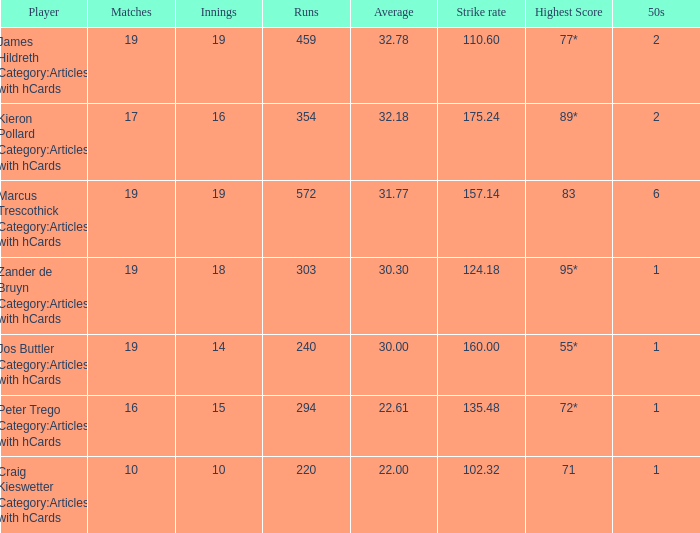What is the strike rate for the player with an average of 32.78? 110.6. 